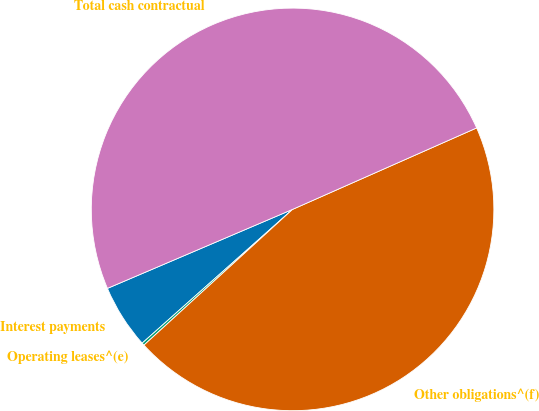<chart> <loc_0><loc_0><loc_500><loc_500><pie_chart><fcel>Interest payments<fcel>Operating leases^(e)<fcel>Other obligations^(f)<fcel>Total cash contractual<nl><fcel>5.15%<fcel>0.21%<fcel>44.85%<fcel>49.79%<nl></chart> 